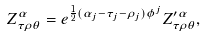Convert formula to latex. <formula><loc_0><loc_0><loc_500><loc_500>Z ^ { \alpha } _ { \tau \rho \theta } = e ^ { \frac { 1 } { 2 } ( \alpha _ { j } - \tau _ { j } - \rho _ { j } ) \phi ^ { j } } Z ^ { \prime \alpha } _ { \tau \rho \theta } ,</formula> 